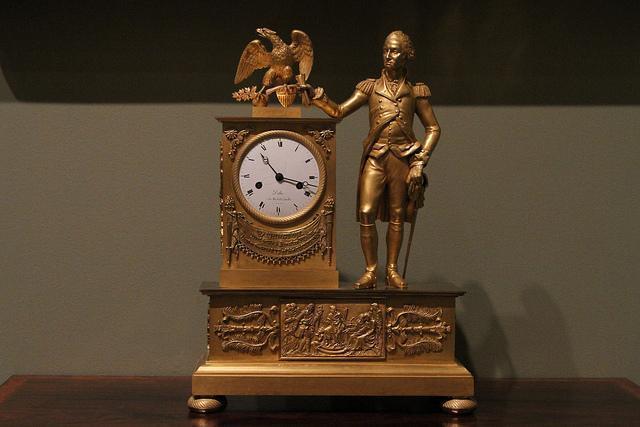How many people are walking under the umbrella?
Give a very brief answer. 0. 